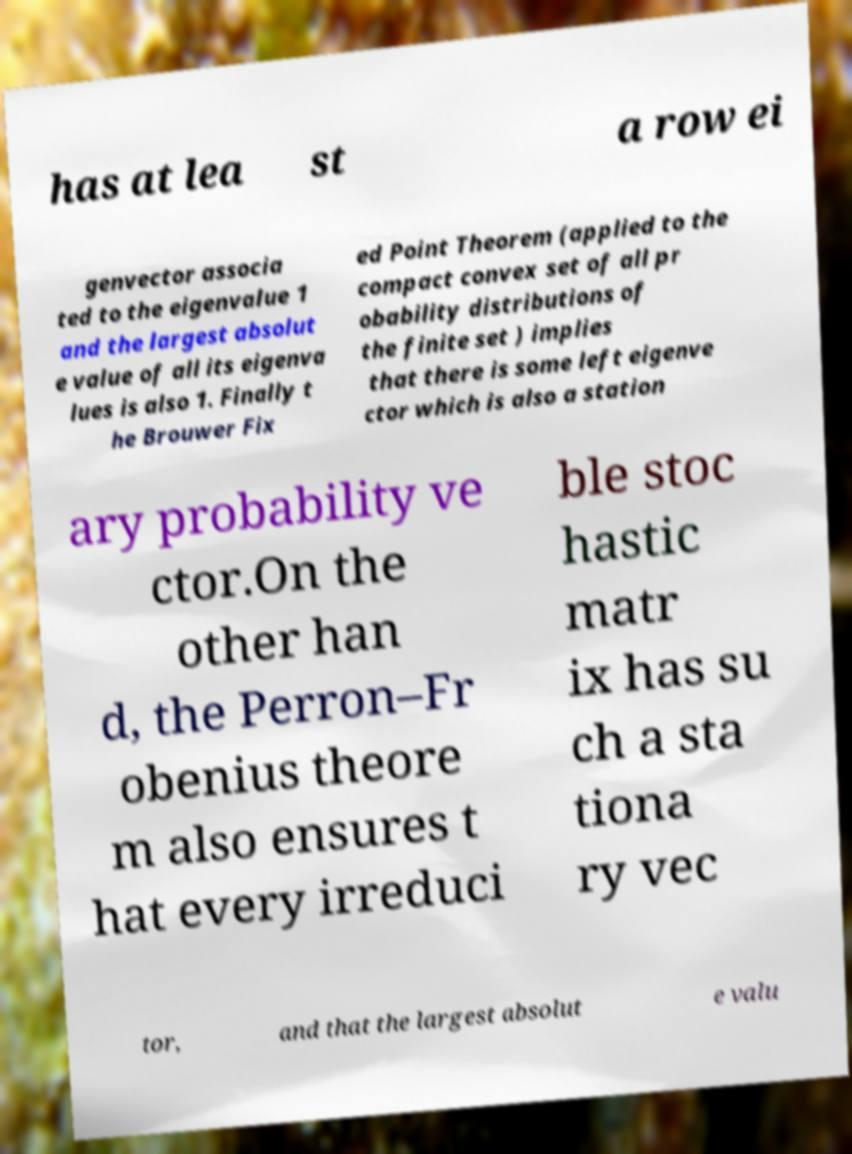I need the written content from this picture converted into text. Can you do that? has at lea st a row ei genvector associa ted to the eigenvalue 1 and the largest absolut e value of all its eigenva lues is also 1. Finally t he Brouwer Fix ed Point Theorem (applied to the compact convex set of all pr obability distributions of the finite set ) implies that there is some left eigenve ctor which is also a station ary probability ve ctor.On the other han d, the Perron–Fr obenius theore m also ensures t hat every irreduci ble stoc hastic matr ix has su ch a sta tiona ry vec tor, and that the largest absolut e valu 